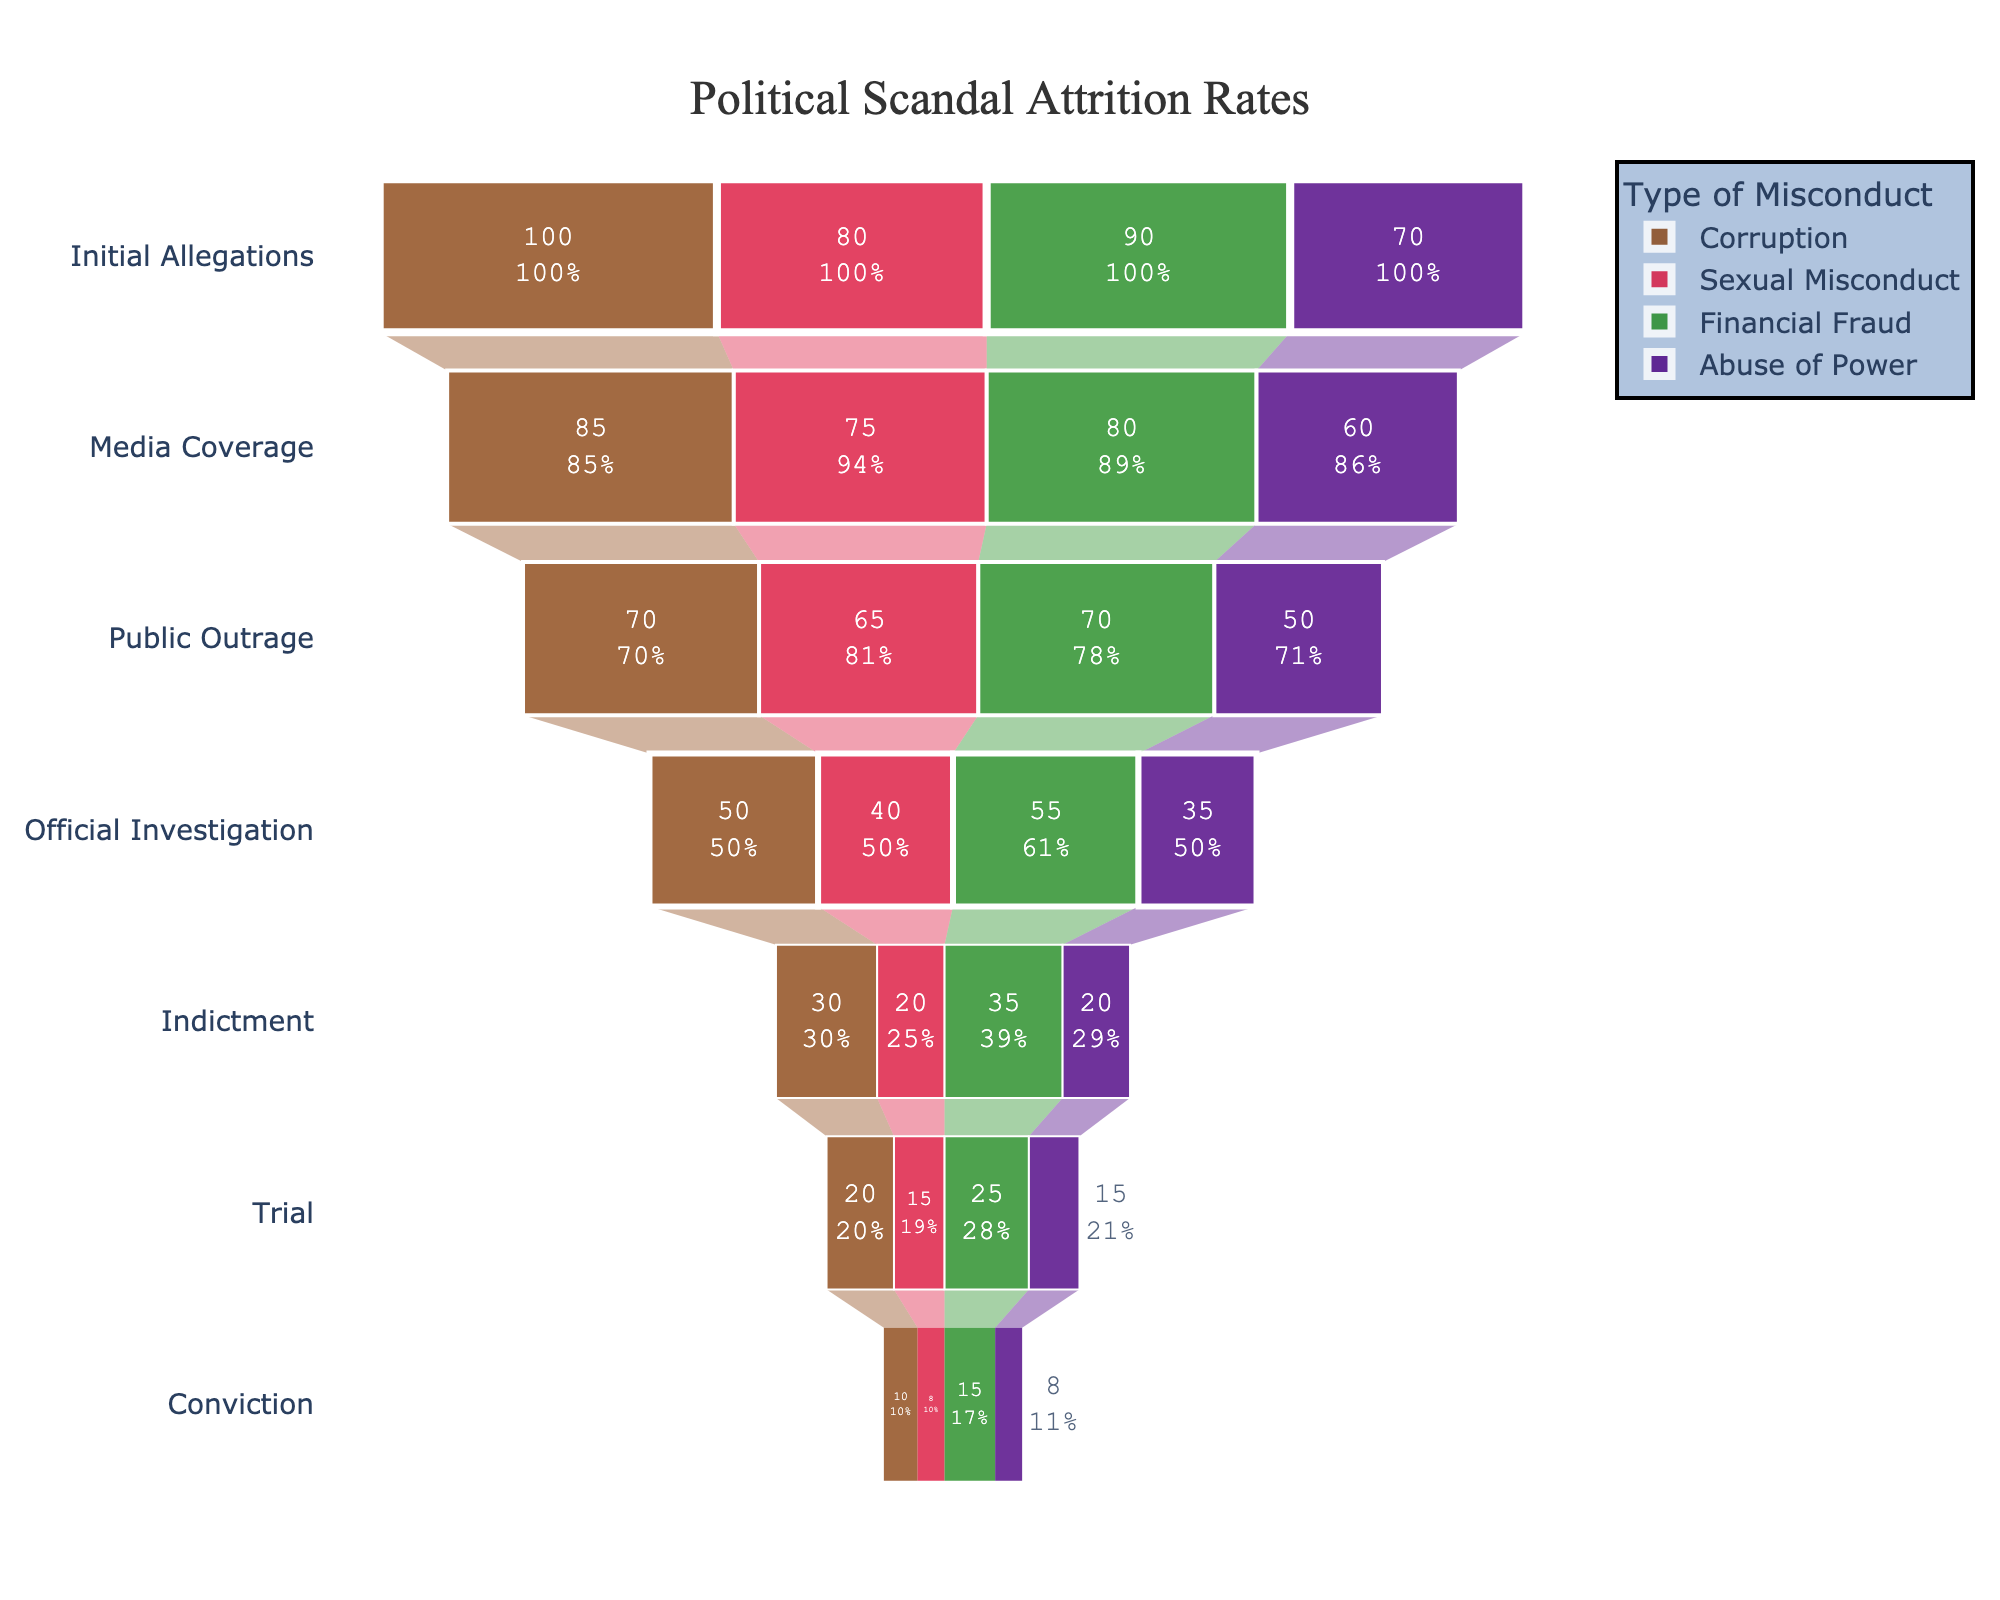What is the title of the funnel chart? The title is located at the top center of the figure. It provides a short summary of what the chart represents.
Answer: Political Scandal Attrition Rates Which type of misconduct has the highest number of initial allegations? By observing the first stage of the funnel chart ('Initial Allegations'), we can compare the values. 'Corruption' has the highest number as it reaches 100 cases.
Answer: Corruption How many stages are present in the funnel chart? Count the unique stages on the y-axis that each funnel segment passes through vertically. These include Initial Allegations, Media Coverage, Public Outrage, Official Investigation, Indictment, Trial, and Conviction.
Answer: 7 stages What is the total number of convictions for Financial Fraud and Abuse of Power combined? Locate the final values for both Financial Fraud and Abuse of Power in the Conviction stage, and then sum those numbers (15 for Financial Fraud and 8 for Abuse of Power).
Answer: 23 Which type of misconduct sees the greatest drop in cases from Initial Allegations to Media Coverage? Calculate the difference between Initial Allegations and Media Coverage for each misconduct type and compare them: Corruption (15), Sexual Misconduct (5), Financial Fraud (10), Abuse of Power (10). The greatest drop is for Corruption.
Answer: Corruption By what percentage does the number of media coverage cases decrease from initial allegations in Sexual Misconduct? Calculate the decrease: (Initial Allegations - Media Coverage). For Sexual Misconduct, it is 80 - 75 = 5. Then, calculate the percentage decrease: (5/80) * 100%.
Answer: 6.25% Which type of misconduct has equal numbers of cases at the Trial and Conviction stages? Observe the counts at both stages for each type. Sexual Misconduct and Abuse of Power have equal numbers at both stages (15 to 8 and 15 to 8).
Answer: Sexual Misconduct, Abuse of Power How many steps are there between 'Public Outrage' and 'Conviction'? Count the number of stages between Public Outrage and Conviction inclusively: Public Outrage, Official Investigation, Indictment, Trial, Conviction.
Answer: 5 steps Is there any stage where the number of cases for a type of misconduct remains unchanged compared to the previous stage? Observe each stage transition for all misconducts. None of the numbers stay the same across any steps.
Answer: No Which type of misconduct has the highest attrition rate from 'Official Investigation' to 'Indictment'? Calculate the attrition by considering the ratio of decrease between the stages. Corruption (50 to 30) has an attrition of 20 out of 50, Sexual Misconduct (40 to 20), Financial Fraud (55 to 35), Abuse of Power (35 to 20). Corruption's rate is 20/50 = 40%.
Answer: Corruption 